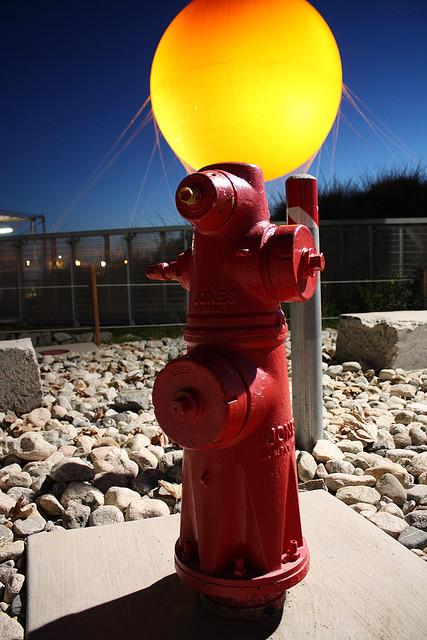Does the fire hydrant work?
Quick response, please. Yes. What color is the sky?
Short answer required. Blue. What color is the fire hydrant?
Quick response, please. Red. 